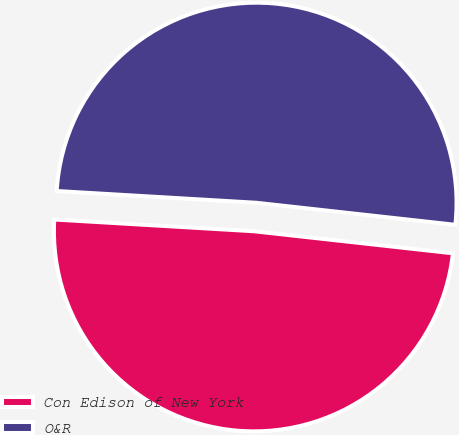Convert chart to OTSL. <chart><loc_0><loc_0><loc_500><loc_500><pie_chart><fcel>Con Edison of New York<fcel>O&R<nl><fcel>49.18%<fcel>50.82%<nl></chart> 